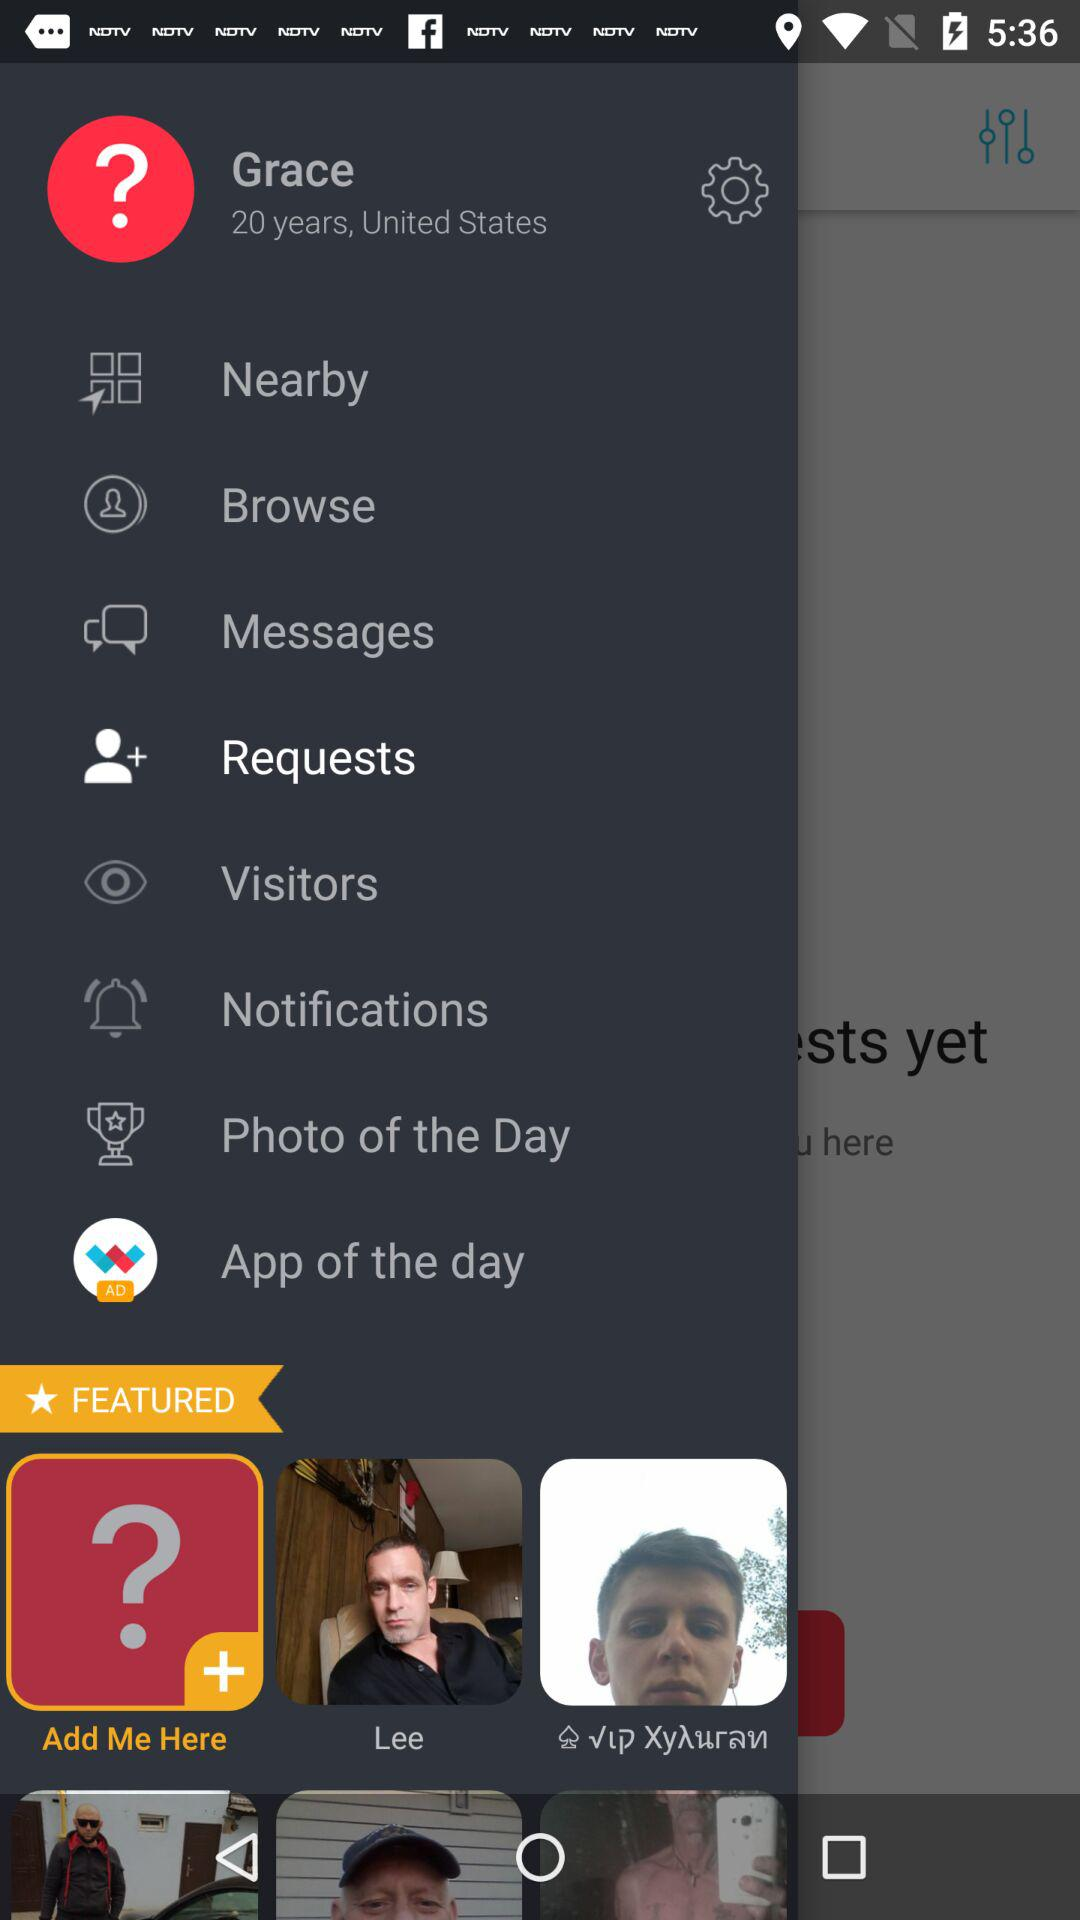What is the location? The location is the United States. 